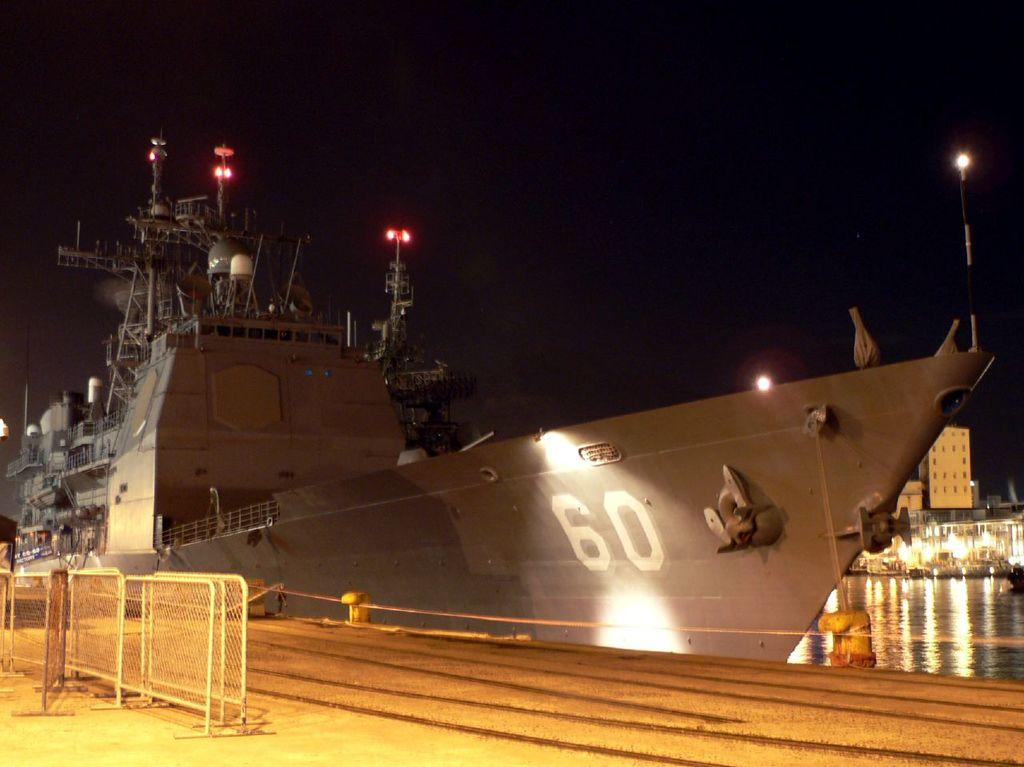<image>
Give a short and clear explanation of the subsequent image. A warship numbered 60 is at its dock. 